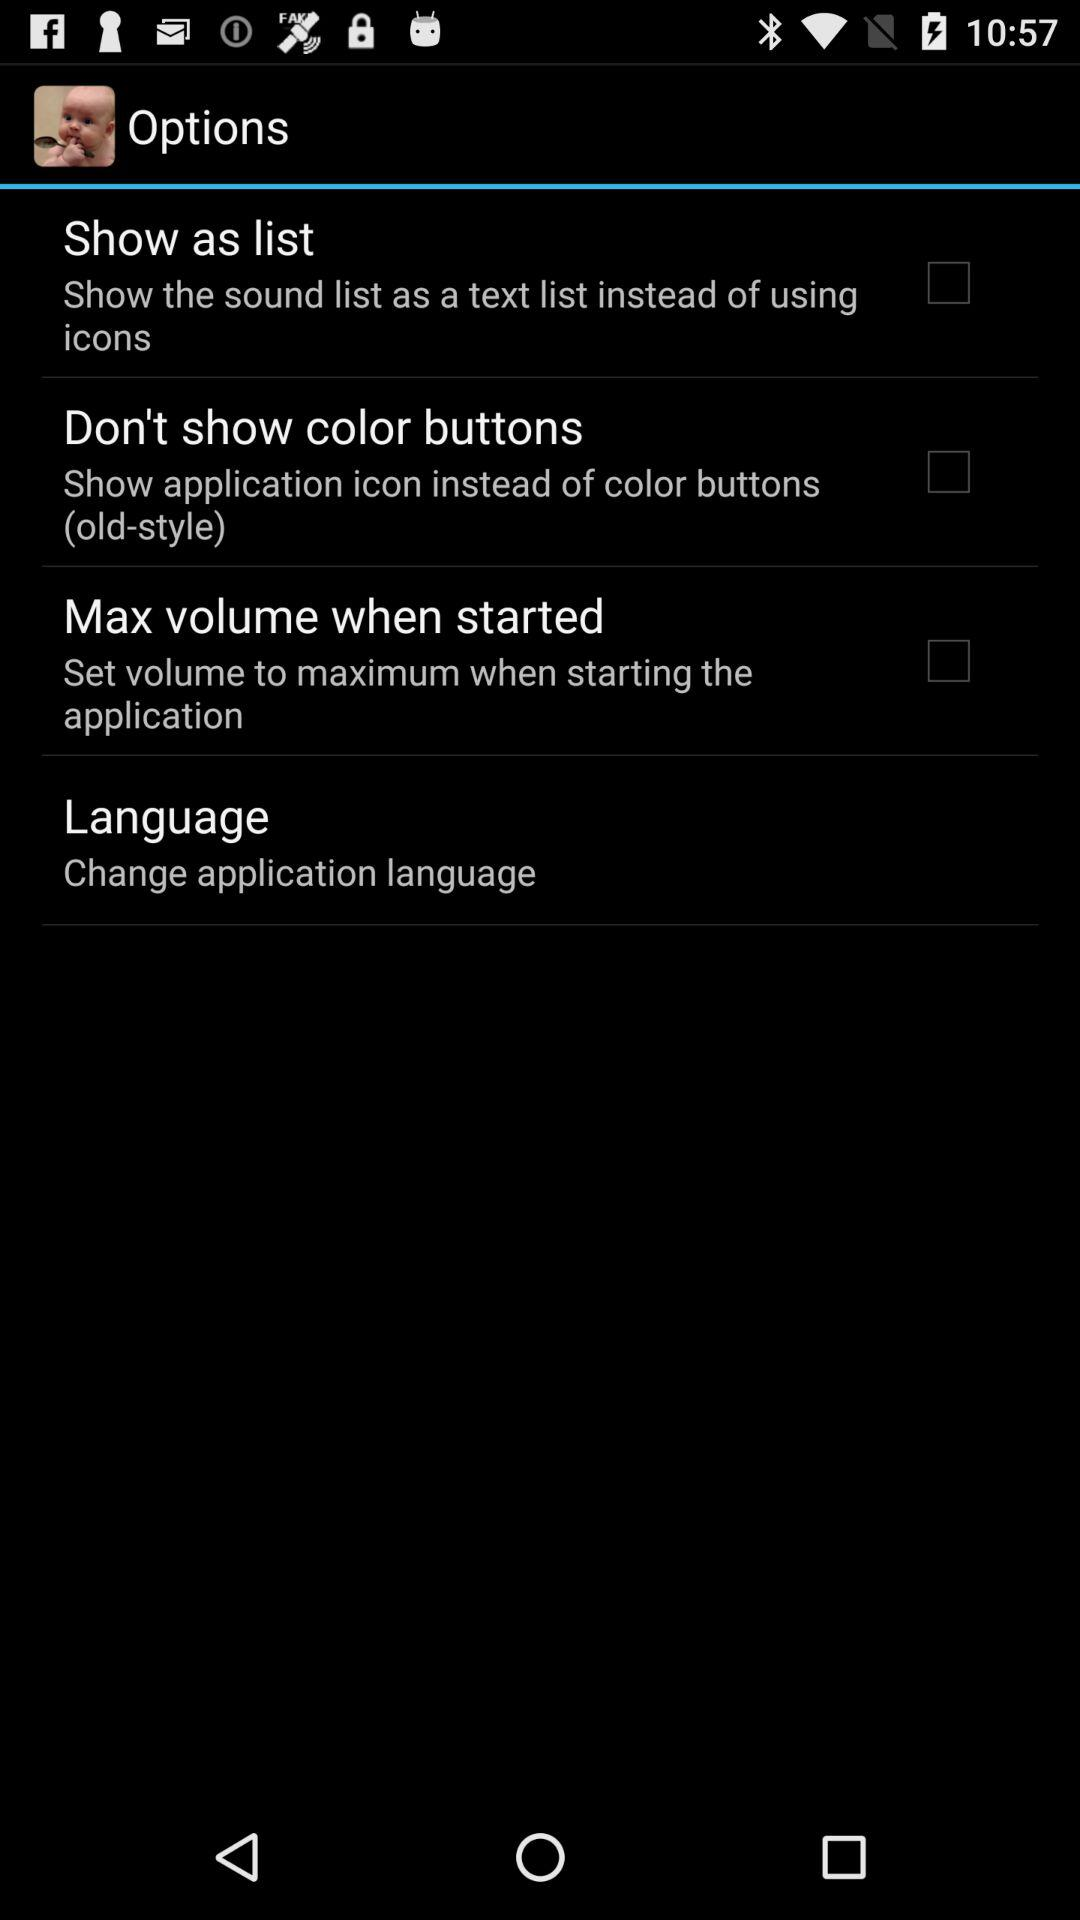What is the status of "Show as list"? The status of "Show as list" is "off". 